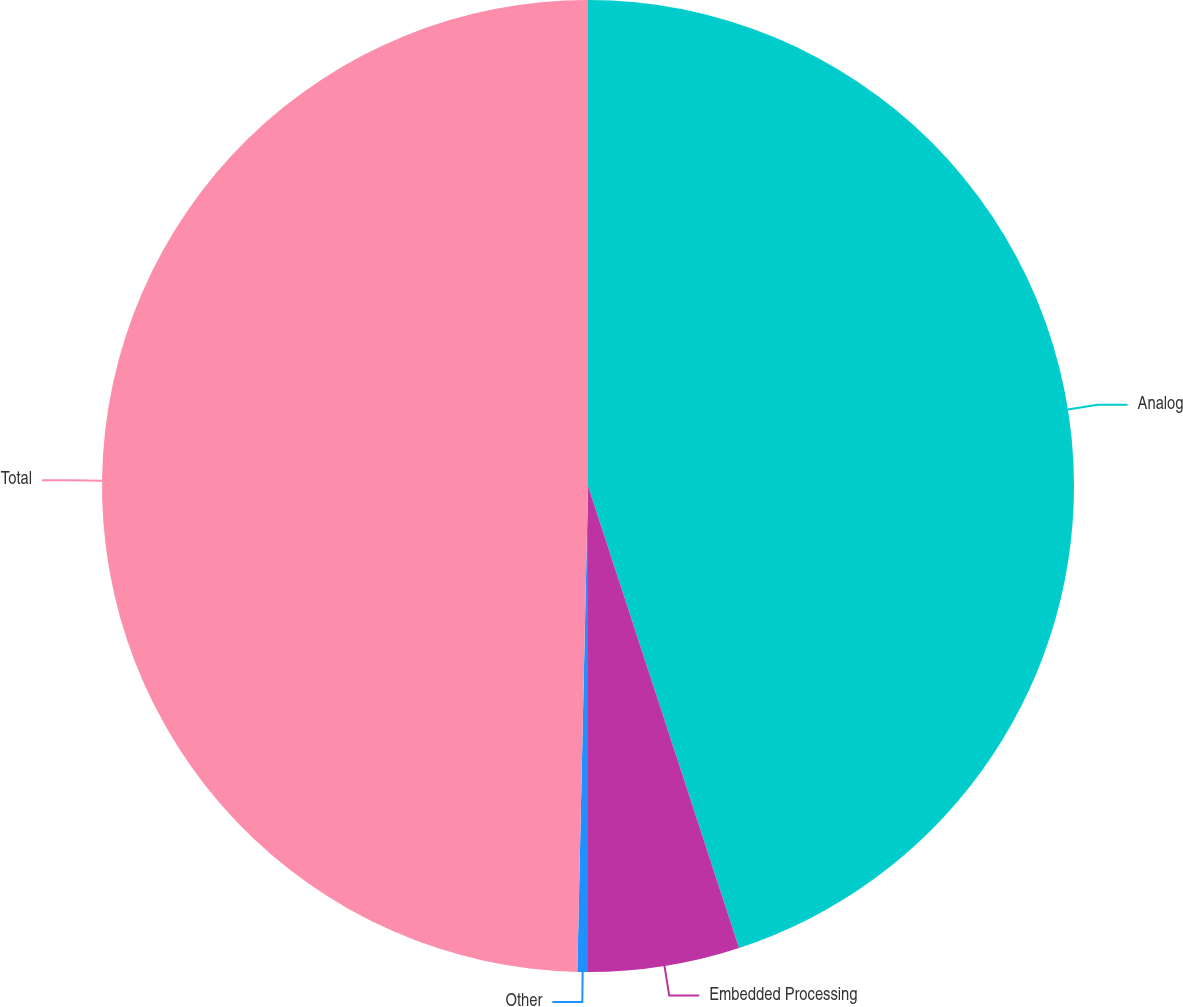Convert chart. <chart><loc_0><loc_0><loc_500><loc_500><pie_chart><fcel>Analog<fcel>Embedded Processing<fcel>Other<fcel>Total<nl><fcel>44.97%<fcel>5.03%<fcel>0.35%<fcel>49.65%<nl></chart> 